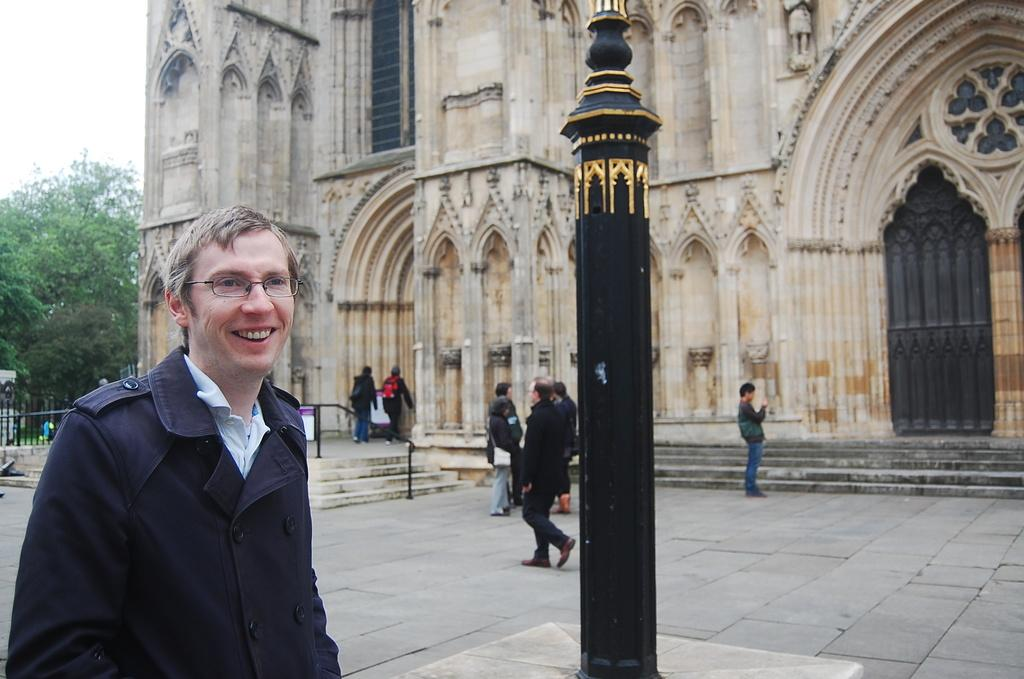Who or what is the main subject in the image? There is a person in the image. Can you describe the surroundings of the person? There are people in the background of the image, and there is a building present. What is the pole in the middle of the image used for? The purpose of the pole is not specified in the image. What type of vegetation can be seen in the image? There is a tree visible in the image. Reasoning: Let'g: Let's think step by step in order to produce the conversation. We start by identifying the main subject in the image, which is the person. Then, we expand the conversation to include the surroundings of the person, such as the people in the background, the building, and the pole and tree. Each question is designed to elicit a specific detail about the image that is known from the provided facts. Absurd Question/Answer: How many chickens are sitting on the person's neck in the image? There are no chickens present in the image, and the person's neck is not visible. What type of park can be seen in the image? There is no park visible in the image. What type of park can be seen in the image? There is no park visible in the image. Reasoning: Let's think step by step in order to produce the conversation. We start by identifying the main subject in the image, which is the person. Then, we expand the conversation to include the surroundings of the person, such as the people in the background, the building, and the pole and tree. Each question is designed to elicit a specific detail about the image that is known from the provided facts. Absurd Question/Answer: How many chickens are sitting on the person's neck in the image? There are no chickens present in the image, and the person's neck is not visible. What type of park can be seen in the image? There is no park visible in the image. 